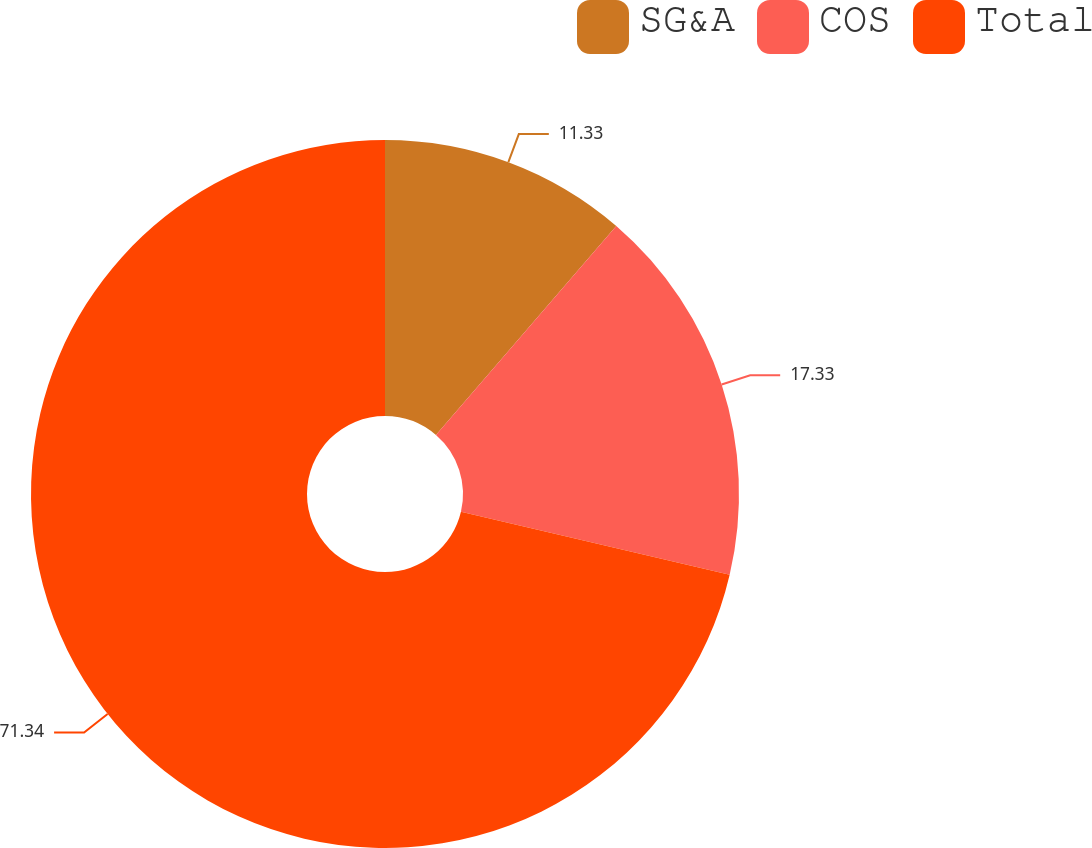<chart> <loc_0><loc_0><loc_500><loc_500><pie_chart><fcel>SG&A<fcel>COS<fcel>Total<nl><fcel>11.33%<fcel>17.33%<fcel>71.33%<nl></chart> 